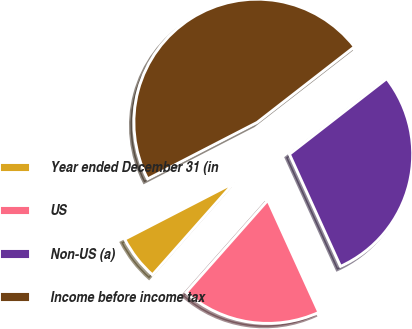Convert chart to OTSL. <chart><loc_0><loc_0><loc_500><loc_500><pie_chart><fcel>Year ended December 31 (in<fcel>US<fcel>Non-US (a)<fcel>Income before income tax<nl><fcel>5.88%<fcel>18.34%<fcel>28.71%<fcel>47.06%<nl></chart> 